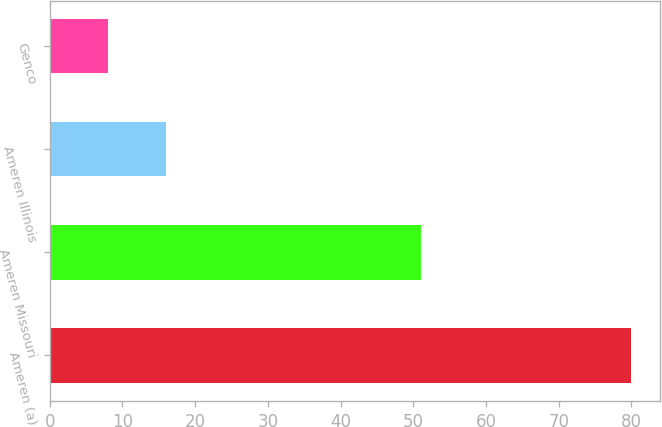Convert chart to OTSL. <chart><loc_0><loc_0><loc_500><loc_500><bar_chart><fcel>Ameren (a)<fcel>Ameren Missouri<fcel>Ameren Illinois<fcel>Genco<nl><fcel>80<fcel>51<fcel>16<fcel>8<nl></chart> 